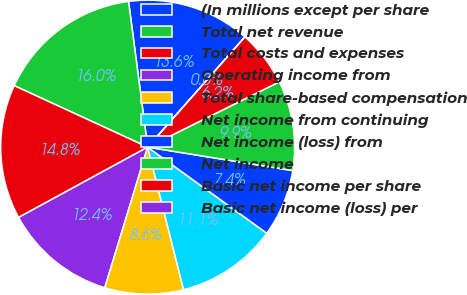Convert chart. <chart><loc_0><loc_0><loc_500><loc_500><pie_chart><fcel>(In millions except per share<fcel>Total net revenue<fcel>Total costs and expenses<fcel>Operating income from<fcel>Total share-based compensation<fcel>Net income from continuing<fcel>Net income (loss) from<fcel>Net income<fcel>Basic net income per share<fcel>Basic net income (loss) per<nl><fcel>13.58%<fcel>16.05%<fcel>14.81%<fcel>12.35%<fcel>8.64%<fcel>11.11%<fcel>7.41%<fcel>9.88%<fcel>6.17%<fcel>0.0%<nl></chart> 